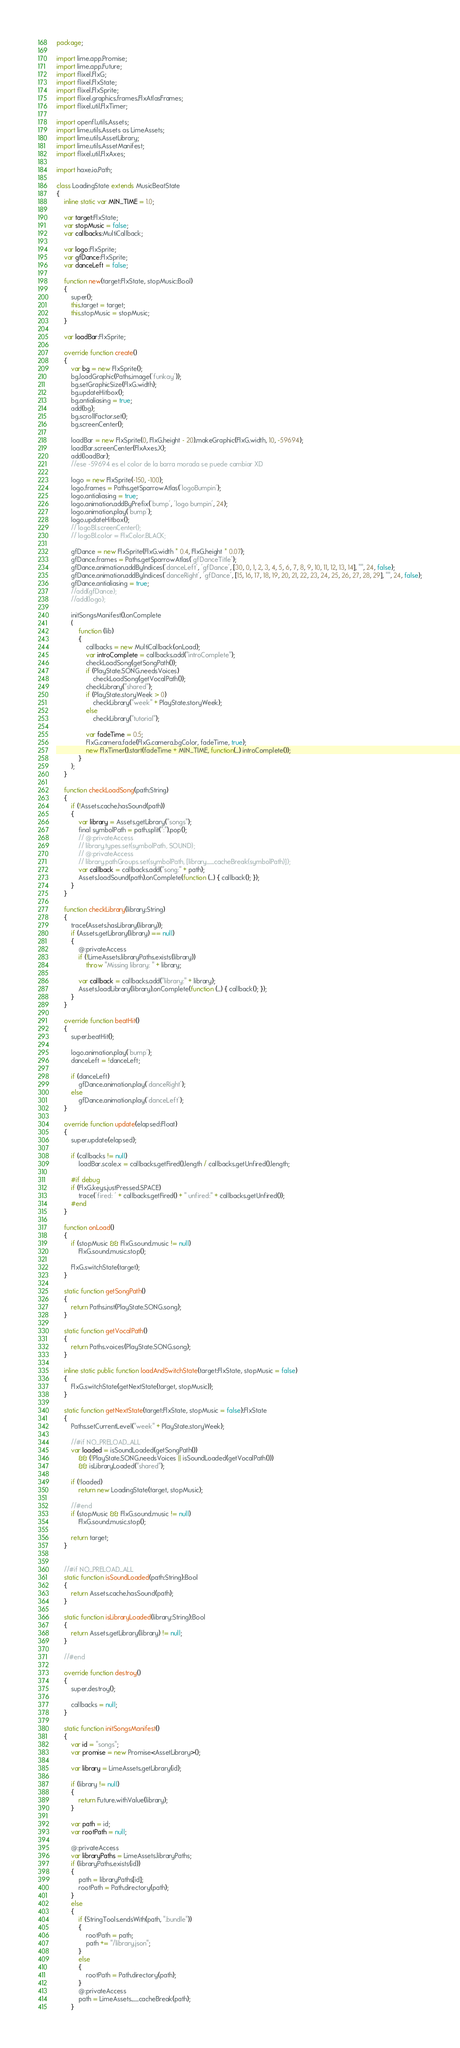Convert code to text. <code><loc_0><loc_0><loc_500><loc_500><_Haxe_>package;

import lime.app.Promise;
import lime.app.Future;
import flixel.FlxG;
import flixel.FlxState;
import flixel.FlxSprite;
import flixel.graphics.frames.FlxAtlasFrames;
import flixel.util.FlxTimer;

import openfl.utils.Assets;
import lime.utils.Assets as LimeAssets;
import lime.utils.AssetLibrary;
import lime.utils.AssetManifest;
import flixel.util.FlxAxes;

import haxe.io.Path;

class LoadingState extends MusicBeatState
{
	inline static var MIN_TIME = 1.0;
	
	var target:FlxState;
	var stopMusic = false;
	var callbacks:MultiCallback;
	
	var logo:FlxSprite;
	var gfDance:FlxSprite;
	var danceLeft = false;
	
	function new(target:FlxState, stopMusic:Bool)
	{
		super();
		this.target = target;
		this.stopMusic = stopMusic;
	}

	var loadBar:FlxSprite;
	
	override function create()
	{
		var bg = new FlxSprite();
		bg.loadGraphic(Paths.image('funkay'));
		bg.setGraphicSize(FlxG.width);
		bg.updateHitbox();
		bg.antialiasing = true;
		add(bg);
		bg.scrollFactor.set();
		bg.screenCenter();

		loadBar = new FlxSprite(0, FlxG.height - 20).makeGraphic(FlxG.width, 10, -59694);
		loadBar.screenCenter(FlxAxes.X);
		add(loadBar);	
		//ese -59694 es el color de la barra morada se puede cambiar XD

		logo = new FlxSprite(-150, -100);
		logo.frames = Paths.getSparrowAtlas('logoBumpin');
		logo.antialiasing = true;
		logo.animation.addByPrefix('bump', 'logo bumpin', 24);
		logo.animation.play('bump');
		logo.updateHitbox();
		// logoBl.screenCenter();
		// logoBl.color = FlxColor.BLACK;

		gfDance = new FlxSprite(FlxG.width * 0.4, FlxG.height * 0.07);
		gfDance.frames = Paths.getSparrowAtlas('gfDanceTitle');
		gfDance.animation.addByIndices('danceLeft', 'gfDance', [30, 0, 1, 2, 3, 4, 5, 6, 7, 8, 9, 10, 11, 12, 13, 14], "", 24, false);
		gfDance.animation.addByIndices('danceRight', 'gfDance', [15, 16, 17, 18, 19, 20, 21, 22, 23, 24, 25, 26, 27, 28, 29], "", 24, false);
		gfDance.antialiasing = true;
		//add(gfDance);
		//add(logo);
		
		initSongsManifest().onComplete
		(
			function (lib)
			{
				callbacks = new MultiCallback(onLoad);
				var introComplete = callbacks.add("introComplete");
				checkLoadSong(getSongPath());
				if (PlayState.SONG.needsVoices)
					checkLoadSong(getVocalPath());
				checkLibrary("shared");
				if (PlayState.storyWeek > 0)
					checkLibrary("week" + PlayState.storyWeek);
				else
					checkLibrary("tutorial");
				
				var fadeTime = 0.5;
				FlxG.camera.fade(FlxG.camera.bgColor, fadeTime, true);
				new FlxTimer().start(fadeTime + MIN_TIME, function(_) introComplete());
			}
		);
	}
	
	function checkLoadSong(path:String)
	{
		if (!Assets.cache.hasSound(path))
		{
			var library = Assets.getLibrary("songs");
			final symbolPath = path.split(":").pop();
			// @:privateAccess
			// library.types.set(symbolPath, SOUND);
			// @:privateAccess
			// library.pathGroups.set(symbolPath, [library.__cacheBreak(symbolPath)]);
			var callback = callbacks.add("song:" + path);
			Assets.loadSound(path).onComplete(function (_) { callback(); });
		}
	}
	
	function checkLibrary(library:String)
	{
		trace(Assets.hasLibrary(library));
		if (Assets.getLibrary(library) == null)
		{
			@:privateAccess
			if (!LimeAssets.libraryPaths.exists(library))
				throw "Missing library: " + library;
			
			var callback = callbacks.add("library:" + library);
			Assets.loadLibrary(library).onComplete(function (_) { callback(); });
		}
	}
	
	override function beatHit()
	{
		super.beatHit();
		
		logo.animation.play('bump');
		danceLeft = !danceLeft;
		
		if (danceLeft)
			gfDance.animation.play('danceRight');
		else
			gfDance.animation.play('danceLeft');
	}
	
	override function update(elapsed:Float)
	{
		super.update(elapsed);

		if (callbacks != null)
			loadBar.scale.x = callbacks.getFired().length / callbacks.getUnfired().length;
		
		#if debug
		if (FlxG.keys.justPressed.SPACE)
			trace('fired: ' + callbacks.getFired() + " unfired:" + callbacks.getUnfired());
		#end
	}
	
	function onLoad()
	{
		if (stopMusic && FlxG.sound.music != null)
			FlxG.sound.music.stop();
		
		FlxG.switchState(target);
	}
	
	static function getSongPath()
	{
		return Paths.inst(PlayState.SONG.song);
	}
	
	static function getVocalPath()
	{
		return Paths.voices(PlayState.SONG.song);
	}
	
	inline static public function loadAndSwitchState(target:FlxState, stopMusic = false)
	{
		FlxG.switchState(getNextState(target, stopMusic));
	}
	
	static function getNextState(target:FlxState, stopMusic = false):FlxState
	{
		Paths.setCurrentLevel("week" + PlayState.storyWeek);

		//#if NO_PRELOAD_ALL
		var loaded = isSoundLoaded(getSongPath())
			&& (!PlayState.SONG.needsVoices || isSoundLoaded(getVocalPath()))
			&& isLibraryLoaded("shared");
		
		if (!loaded)
			return new LoadingState(target, stopMusic);

		//#end
		if (stopMusic && FlxG.sound.music != null)
			FlxG.sound.music.stop();
		
		return target;
	}
	

	//#if NO_PRELOAD_ALL
	static function isSoundLoaded(path:String):Bool
	{
		return Assets.cache.hasSound(path);
	}
	
	static function isLibraryLoaded(library:String):Bool
	{
		return Assets.getLibrary(library) != null;
	}

	//#end
	
	override function destroy()
	{
		super.destroy();
		
		callbacks = null;
	}
	
	static function initSongsManifest()
	{
		var id = "songs";
		var promise = new Promise<AssetLibrary>();

		var library = LimeAssets.getLibrary(id);

		if (library != null)
		{
			return Future.withValue(library);
		}

		var path = id;
		var rootPath = null;

		@:privateAccess
		var libraryPaths = LimeAssets.libraryPaths;
		if (libraryPaths.exists(id))
		{
			path = libraryPaths[id];
			rootPath = Path.directory(path);
		}
		else
		{
			if (StringTools.endsWith(path, ".bundle"))
			{
				rootPath = path;
				path += "/library.json";
			}
			else
			{
				rootPath = Path.directory(path);
			}
			@:privateAccess
			path = LimeAssets.__cacheBreak(path);
		}
</code> 